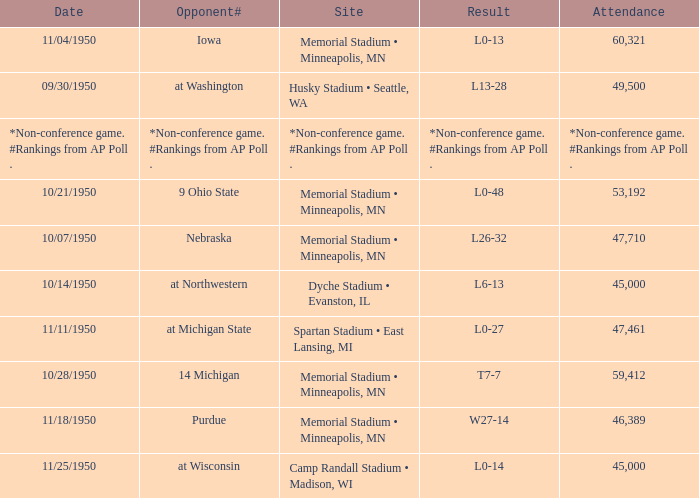What is the Attendance when the Result is l0-13? 60321.0. 